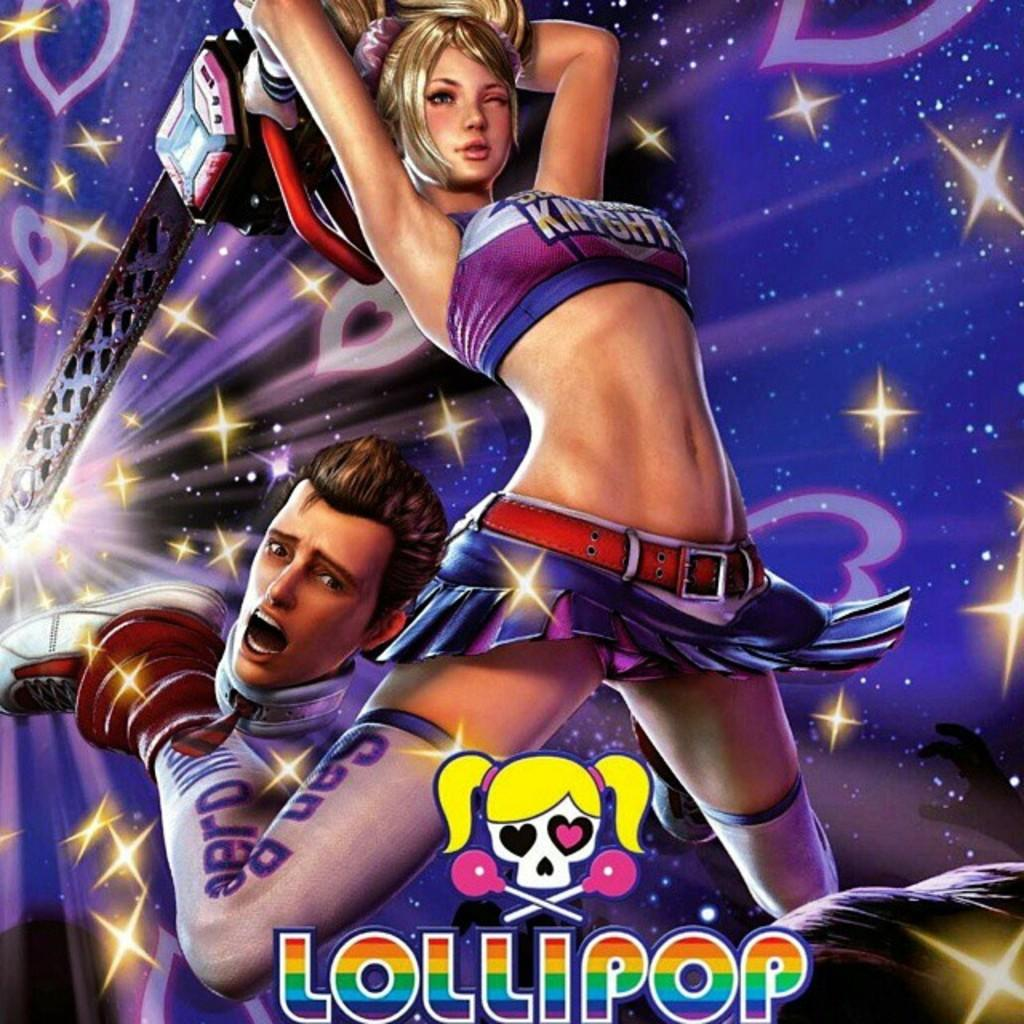<image>
Write a terse but informative summary of the picture. An animated poster for Lollipop that features a girl wielding a chainsaw. 